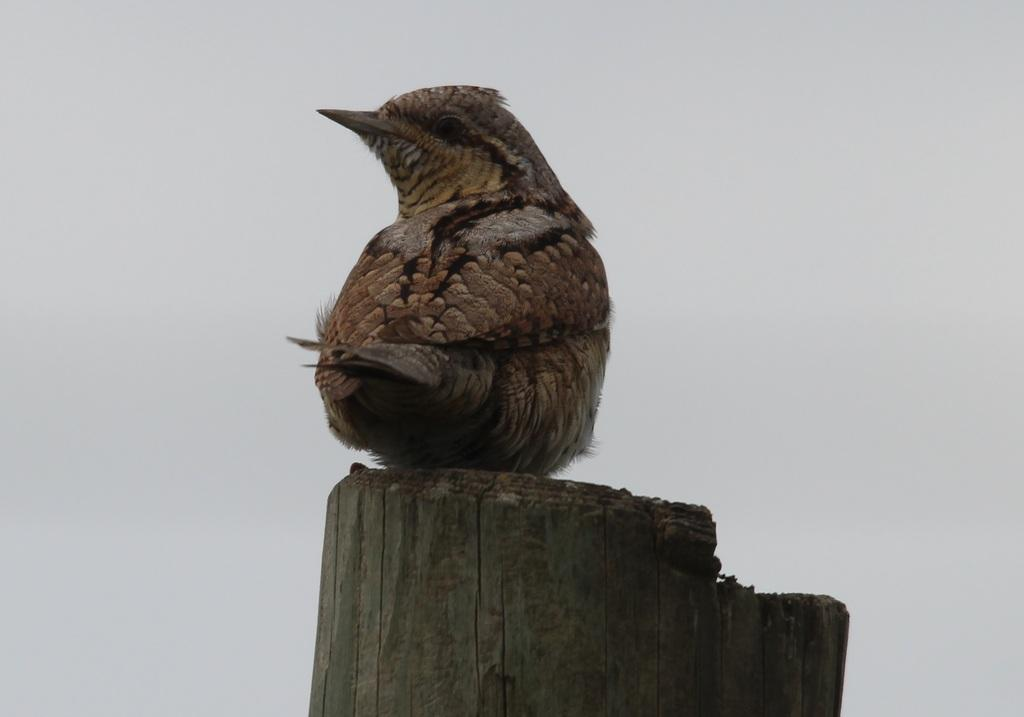What type of bird can be seen in the image? There is a brown color bird in the image. Where is the bird sitting? The bird is sitting on a wooden bamboo. What can be seen in the background of the image? There is a sky visible in the background of the image. What is the name of the music playing in the background of the image? There is no music playing in the background of the image. How many snails can be seen crawling on the wooden bamboo in the image? There are no snails present in the image; it features a brown color bird sitting on a wooden bamboo. 